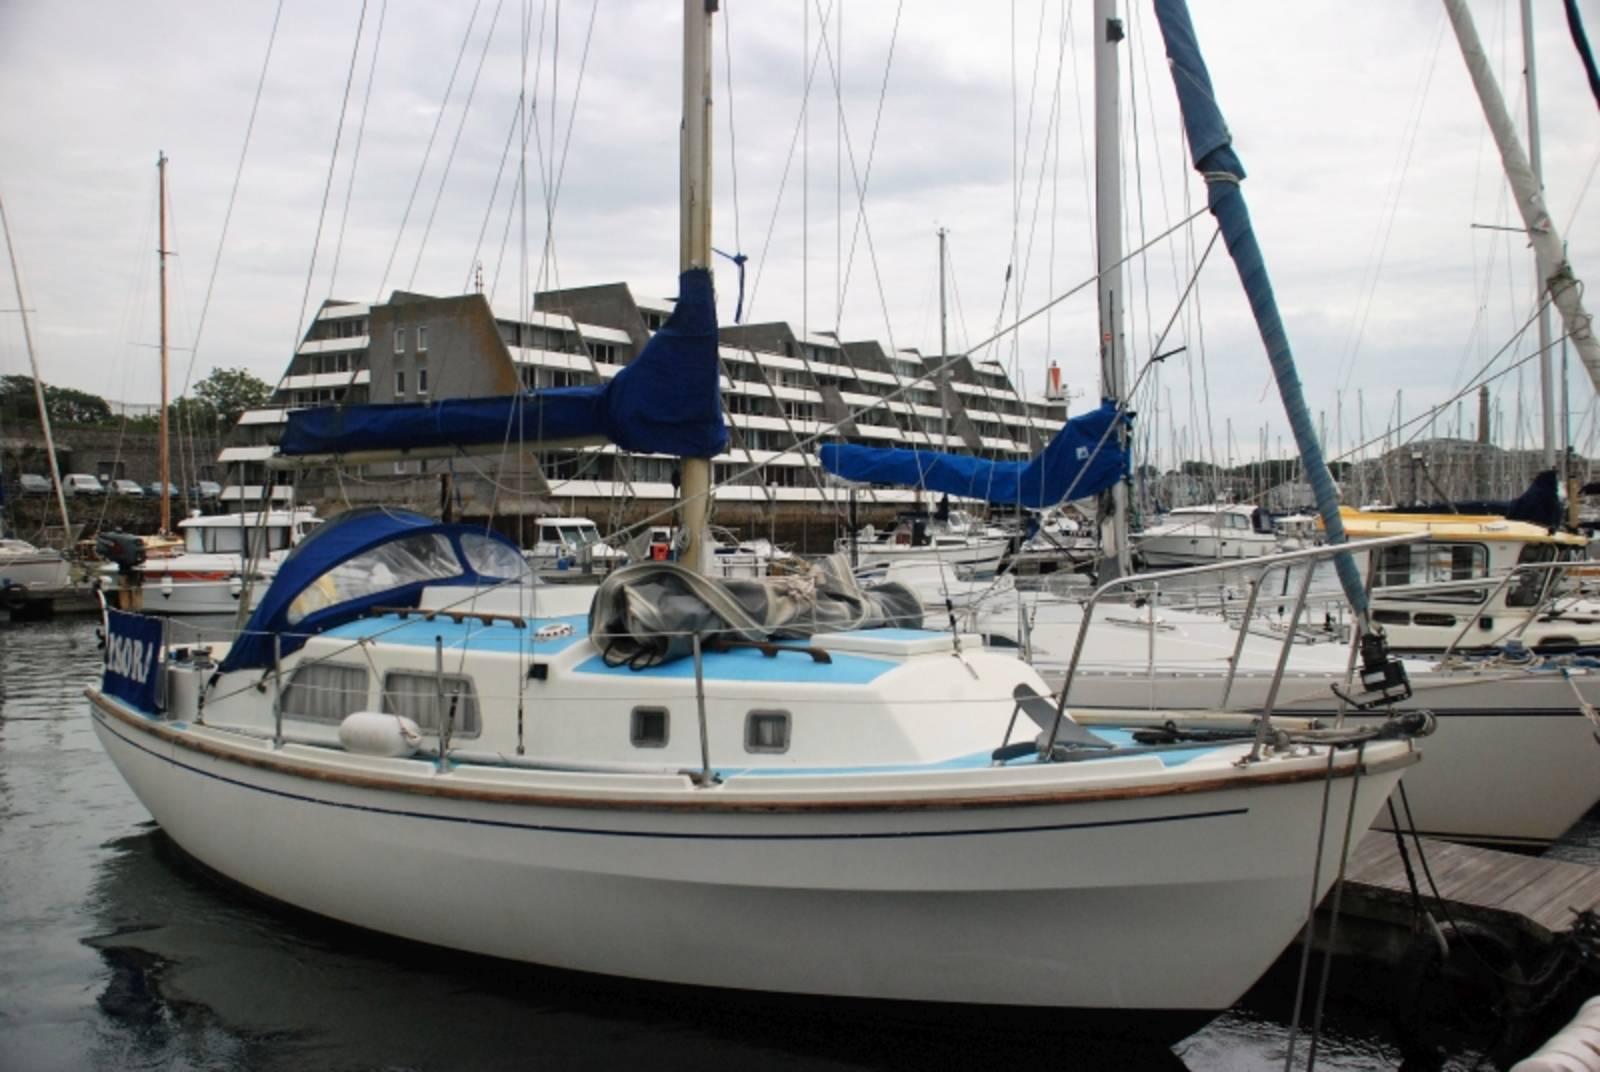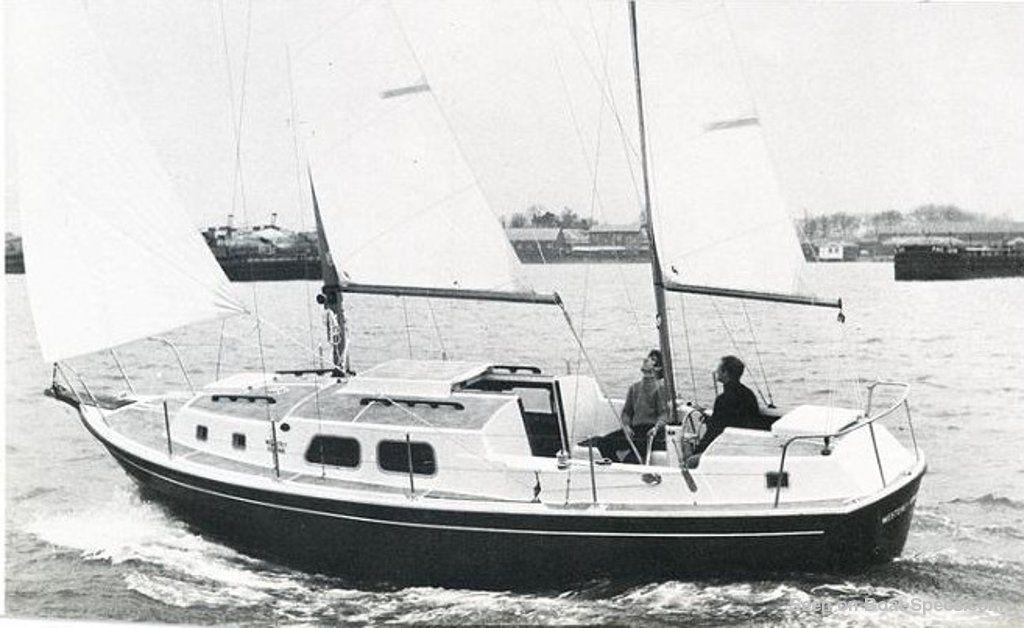The first image is the image on the left, the second image is the image on the right. Assess this claim about the two images: "There are at least two blue sails.". Correct or not? Answer yes or no. Yes. The first image is the image on the left, the second image is the image on the right. Evaluate the accuracy of this statement regarding the images: "All of the sailboats pictured a currently moored or a at a dock.". Is it true? Answer yes or no. No. 